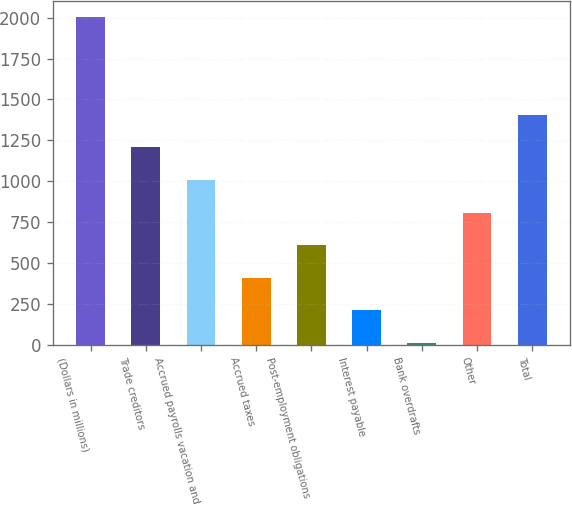Convert chart to OTSL. <chart><loc_0><loc_0><loc_500><loc_500><bar_chart><fcel>(Dollars in millions)<fcel>Trade creditors<fcel>Accrued payrolls vacation and<fcel>Accrued taxes<fcel>Post-employment obligations<fcel>Interest payable<fcel>Bank overdrafts<fcel>Other<fcel>Total<nl><fcel>2005<fcel>1207<fcel>1007.5<fcel>409<fcel>608.5<fcel>209.5<fcel>10<fcel>808<fcel>1406.5<nl></chart> 